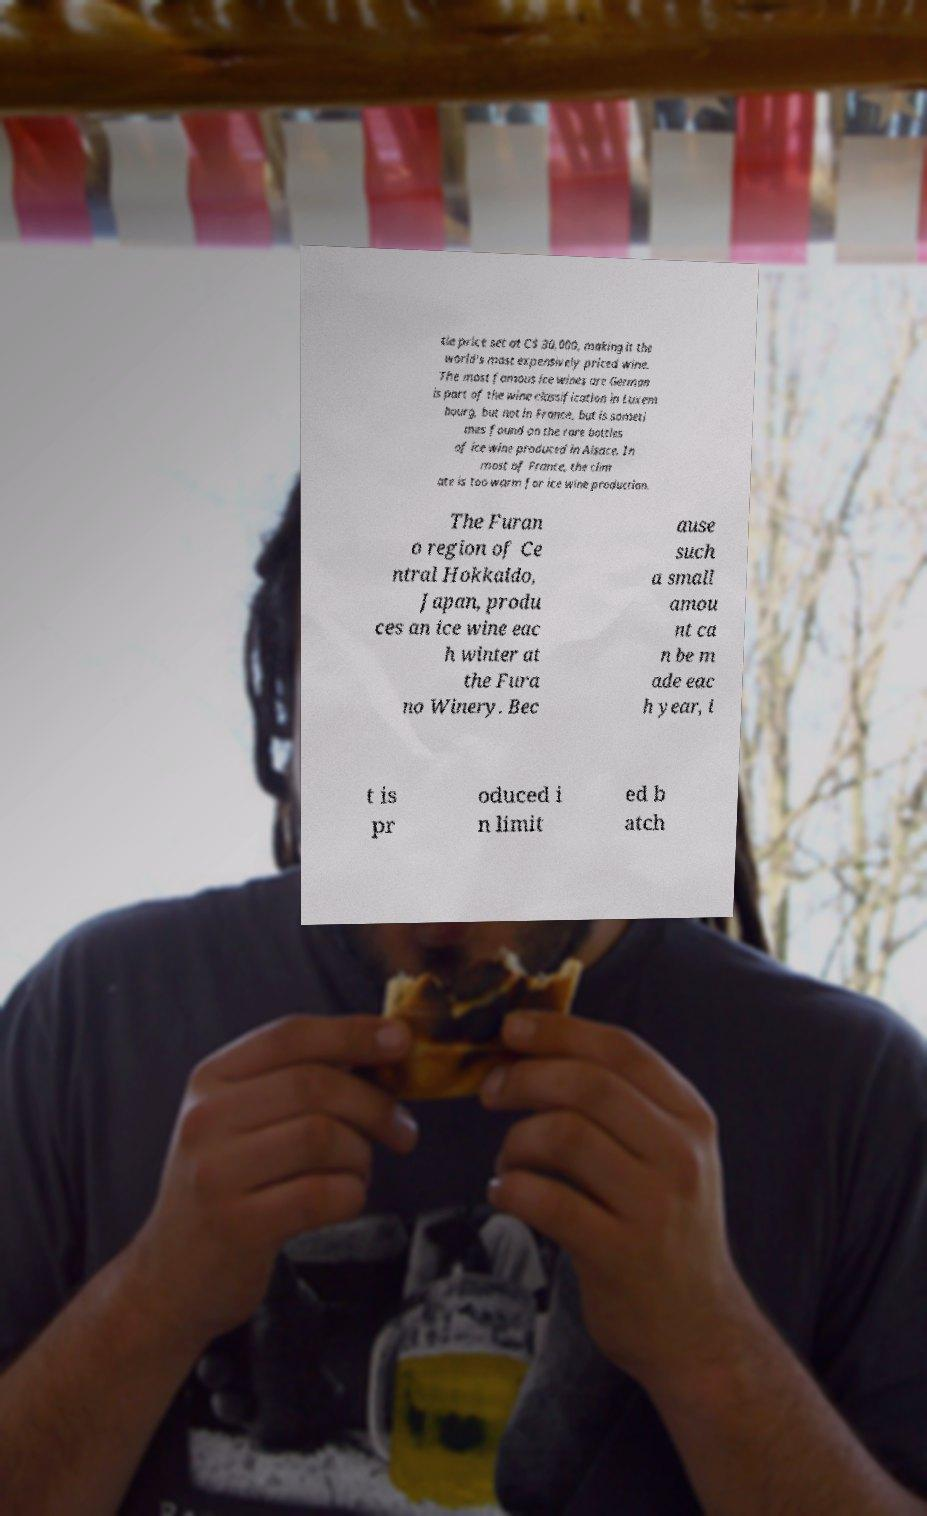Can you accurately transcribe the text from the provided image for me? tle price set at C$ 30,000, making it the world's most expensively priced wine. The most famous ice wines are German is part of the wine classification in Luxem bourg, but not in France, but is someti mes found on the rare bottles of ice wine produced in Alsace. In most of France, the clim ate is too warm for ice wine production. The Furan o region of Ce ntral Hokkaido, Japan, produ ces an ice wine eac h winter at the Fura no Winery. Bec ause such a small amou nt ca n be m ade eac h year, i t is pr oduced i n limit ed b atch 